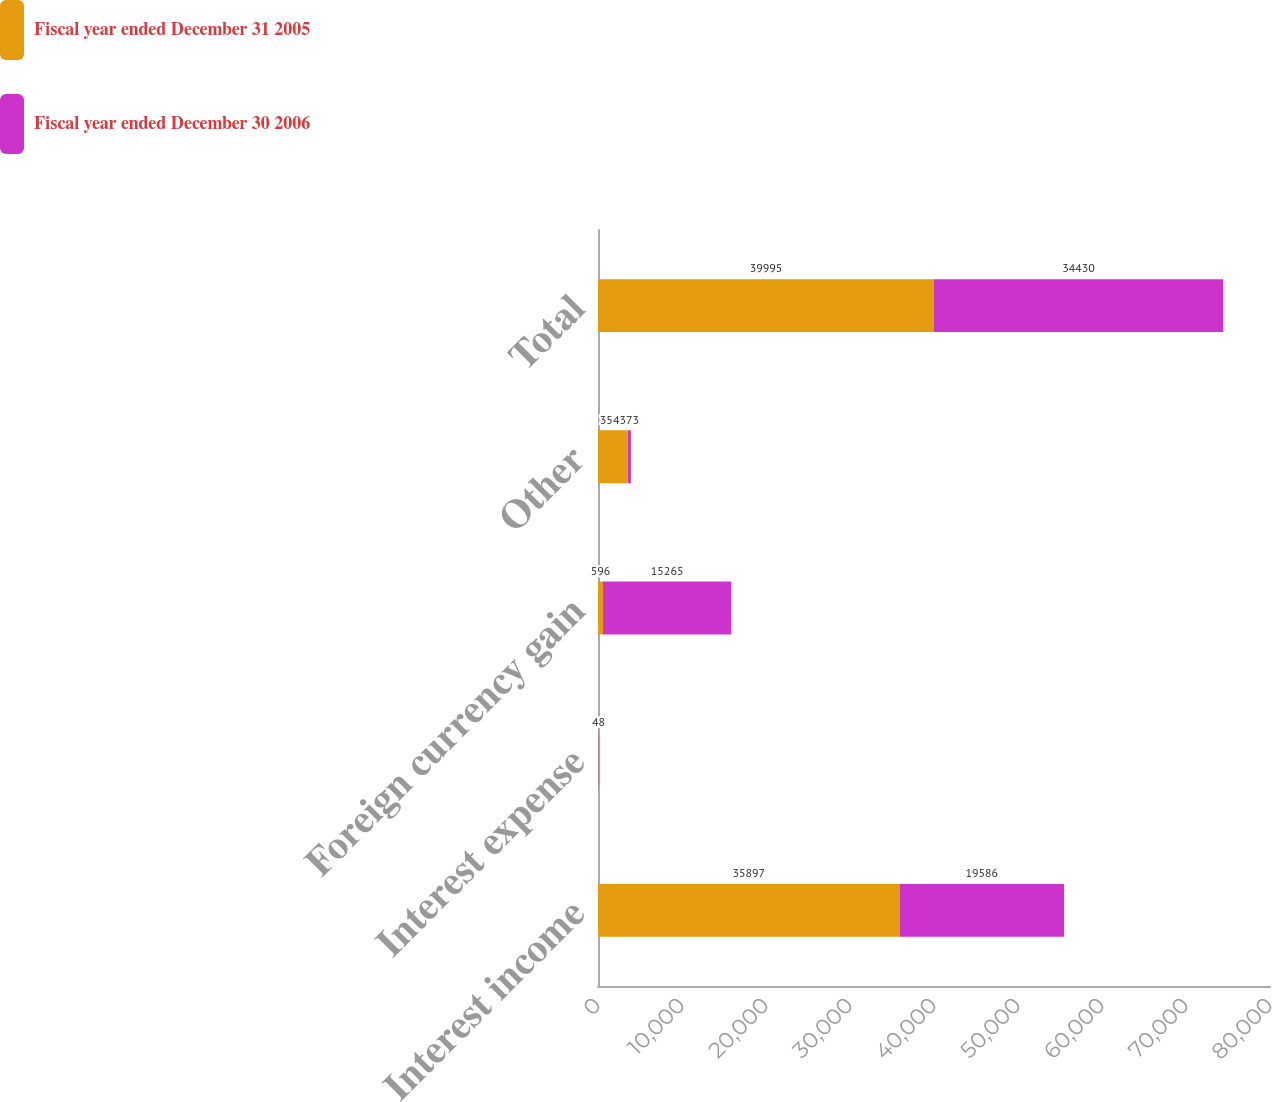Convert chart to OTSL. <chart><loc_0><loc_0><loc_500><loc_500><stacked_bar_chart><ecel><fcel>Interest income<fcel>Interest expense<fcel>Foreign currency gain<fcel>Other<fcel>Total<nl><fcel>Fiscal year ended December 31 2005<fcel>35897<fcel>41<fcel>596<fcel>3543<fcel>39995<nl><fcel>Fiscal year ended December 30 2006<fcel>19586<fcel>48<fcel>15265<fcel>373<fcel>34430<nl></chart> 